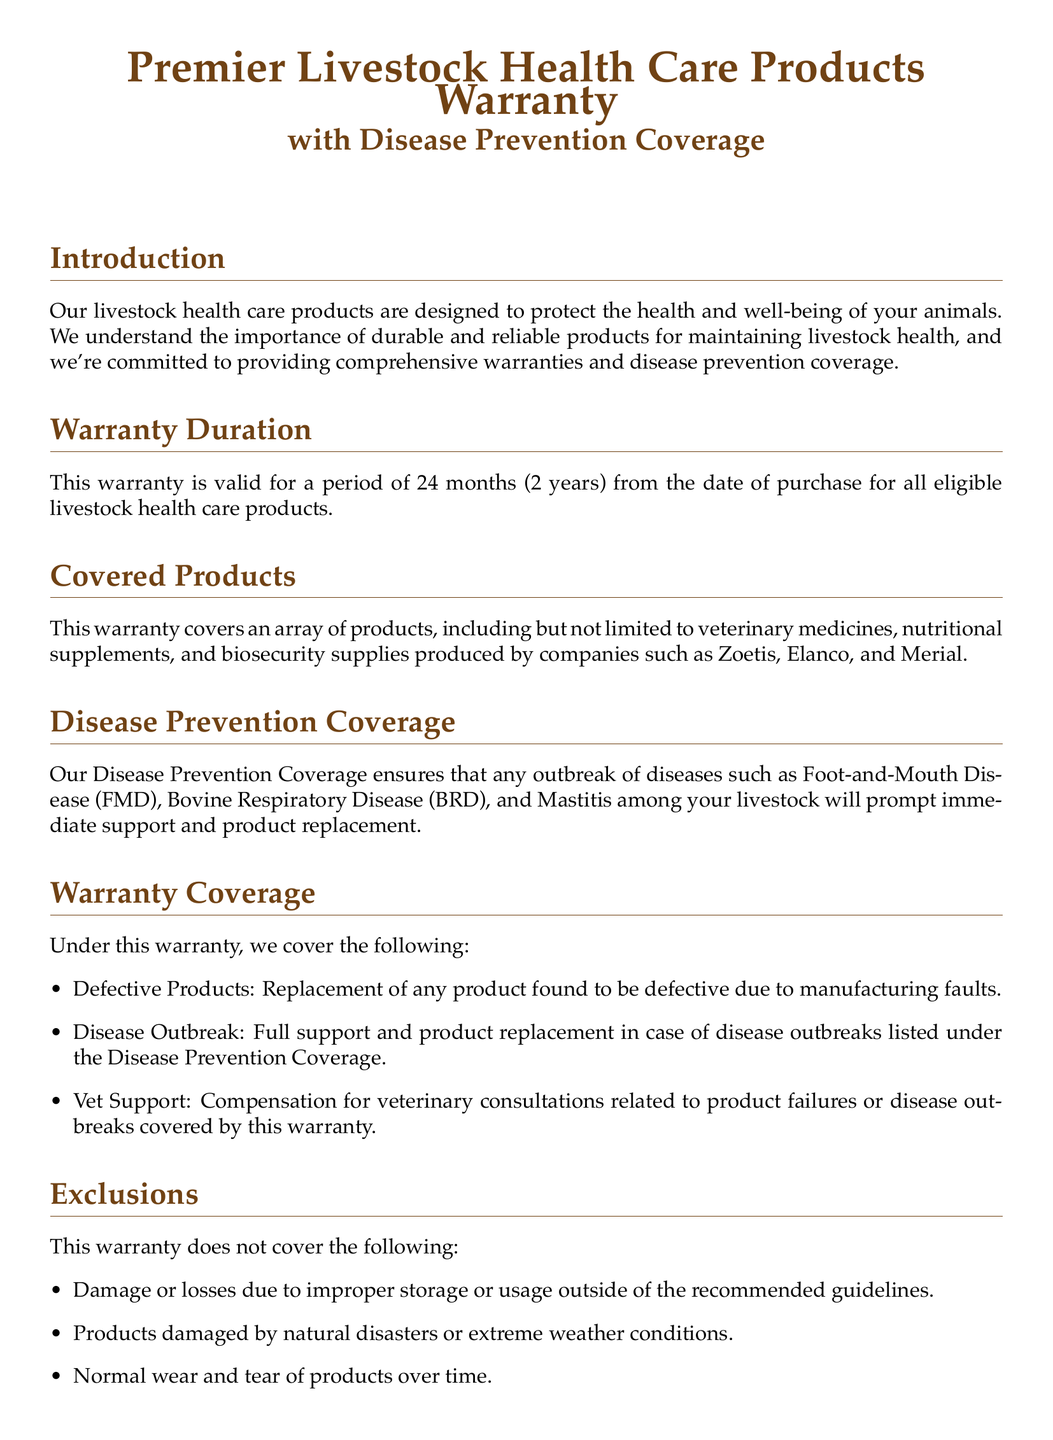what is the duration of the warranty? The warranty is valid for a period of 24 months from the date of purchase.
Answer: 24 months which products are covered under this warranty? The warranty covers veterinary medicines, nutritional supplements, and biosecurity supplies.
Answer: veterinary medicines, nutritional supplements, and biosecurity supplies what diseases are included in the Disease Prevention Coverage? The diseases covered include Foot-and-Mouth Disease, Bovine Respiratory Disease, and Mastitis.
Answer: Foot-and-Mouth Disease, Bovine Respiratory Disease, and Mastitis what is the claim process step? The first step in the claim process is to contact customer support with your purchase details.
Answer: contact customer support what should customers maintain to enhance product effectiveness? Customers should maintain proper storage conditions and usage protocols as indicated.
Answer: proper storage conditions and usage protocols what is the effective date of the warranty? The effective date of this warranty is for all purchases made from January 1, 2022, onwards.
Answer: January 1, 2022 what is the phone number for customer service? The contact number for customer service provided in the document is 1-800-FARM-CARE.
Answer: 1-800-FARM-CARE what does the warranty exclude? The warranty excludes damage or losses due to improper storage or usage outside of the recommended guidelines.
Answer: damage or losses due to improper storage or usage 